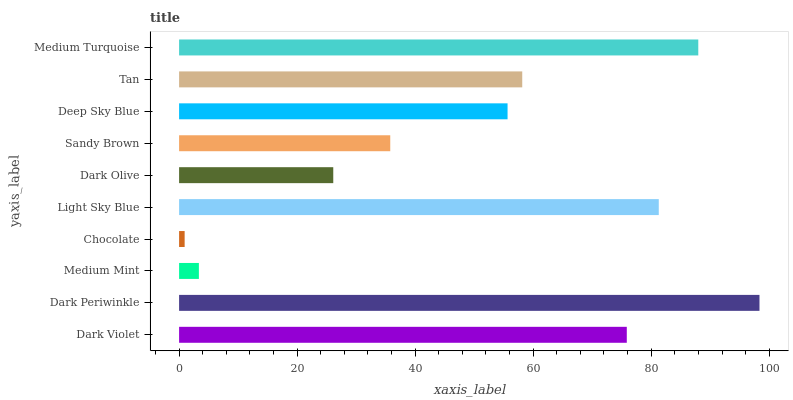Is Chocolate the minimum?
Answer yes or no. Yes. Is Dark Periwinkle the maximum?
Answer yes or no. Yes. Is Medium Mint the minimum?
Answer yes or no. No. Is Medium Mint the maximum?
Answer yes or no. No. Is Dark Periwinkle greater than Medium Mint?
Answer yes or no. Yes. Is Medium Mint less than Dark Periwinkle?
Answer yes or no. Yes. Is Medium Mint greater than Dark Periwinkle?
Answer yes or no. No. Is Dark Periwinkle less than Medium Mint?
Answer yes or no. No. Is Tan the high median?
Answer yes or no. Yes. Is Deep Sky Blue the low median?
Answer yes or no. Yes. Is Deep Sky Blue the high median?
Answer yes or no. No. Is Tan the low median?
Answer yes or no. No. 